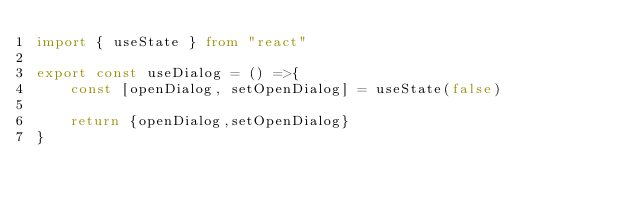Convert code to text. <code><loc_0><loc_0><loc_500><loc_500><_TypeScript_>import { useState } from "react"

export const useDialog = () =>{
    const [openDialog, setOpenDialog] = useState(false)

    return {openDialog,setOpenDialog}
}</code> 